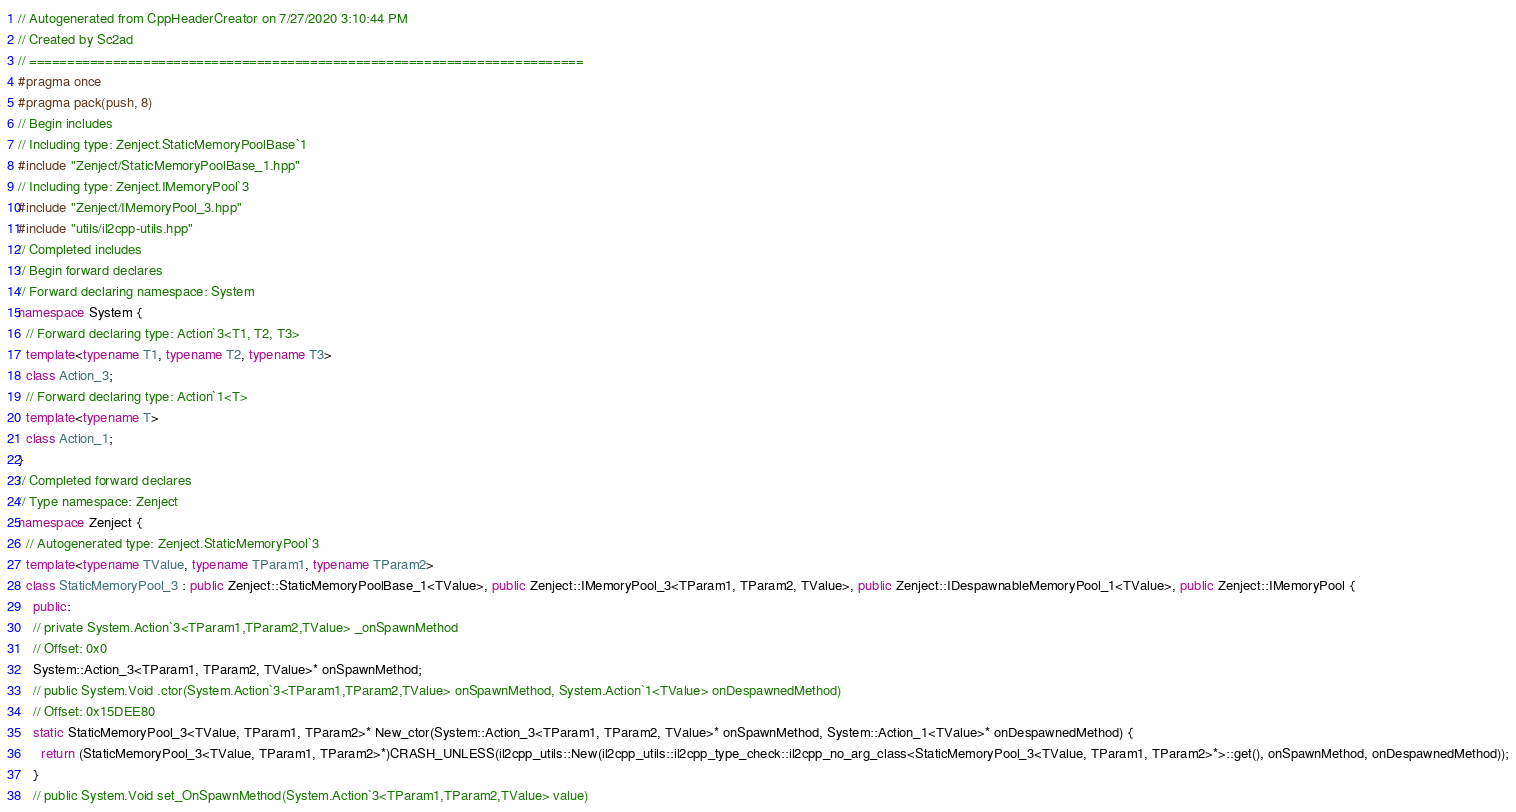Convert code to text. <code><loc_0><loc_0><loc_500><loc_500><_C++_>// Autogenerated from CppHeaderCreator on 7/27/2020 3:10:44 PM
// Created by Sc2ad
// =========================================================================
#pragma once
#pragma pack(push, 8)
// Begin includes
// Including type: Zenject.StaticMemoryPoolBase`1
#include "Zenject/StaticMemoryPoolBase_1.hpp"
// Including type: Zenject.IMemoryPool`3
#include "Zenject/IMemoryPool_3.hpp"
#include "utils/il2cpp-utils.hpp"
// Completed includes
// Begin forward declares
// Forward declaring namespace: System
namespace System {
  // Forward declaring type: Action`3<T1, T2, T3>
  template<typename T1, typename T2, typename T3>
  class Action_3;
  // Forward declaring type: Action`1<T>
  template<typename T>
  class Action_1;
}
// Completed forward declares
// Type namespace: Zenject
namespace Zenject {
  // Autogenerated type: Zenject.StaticMemoryPool`3
  template<typename TValue, typename TParam1, typename TParam2>
  class StaticMemoryPool_3 : public Zenject::StaticMemoryPoolBase_1<TValue>, public Zenject::IMemoryPool_3<TParam1, TParam2, TValue>, public Zenject::IDespawnableMemoryPool_1<TValue>, public Zenject::IMemoryPool {
    public:
    // private System.Action`3<TParam1,TParam2,TValue> _onSpawnMethod
    // Offset: 0x0
    System::Action_3<TParam1, TParam2, TValue>* onSpawnMethod;
    // public System.Void .ctor(System.Action`3<TParam1,TParam2,TValue> onSpawnMethod, System.Action`1<TValue> onDespawnedMethod)
    // Offset: 0x15DEE80
    static StaticMemoryPool_3<TValue, TParam1, TParam2>* New_ctor(System::Action_3<TParam1, TParam2, TValue>* onSpawnMethod, System::Action_1<TValue>* onDespawnedMethod) {
      return (StaticMemoryPool_3<TValue, TParam1, TParam2>*)CRASH_UNLESS(il2cpp_utils::New(il2cpp_utils::il2cpp_type_check::il2cpp_no_arg_class<StaticMemoryPool_3<TValue, TParam1, TParam2>*>::get(), onSpawnMethod, onDespawnedMethod));
    }
    // public System.Void set_OnSpawnMethod(System.Action`3<TParam1,TParam2,TValue> value)</code> 